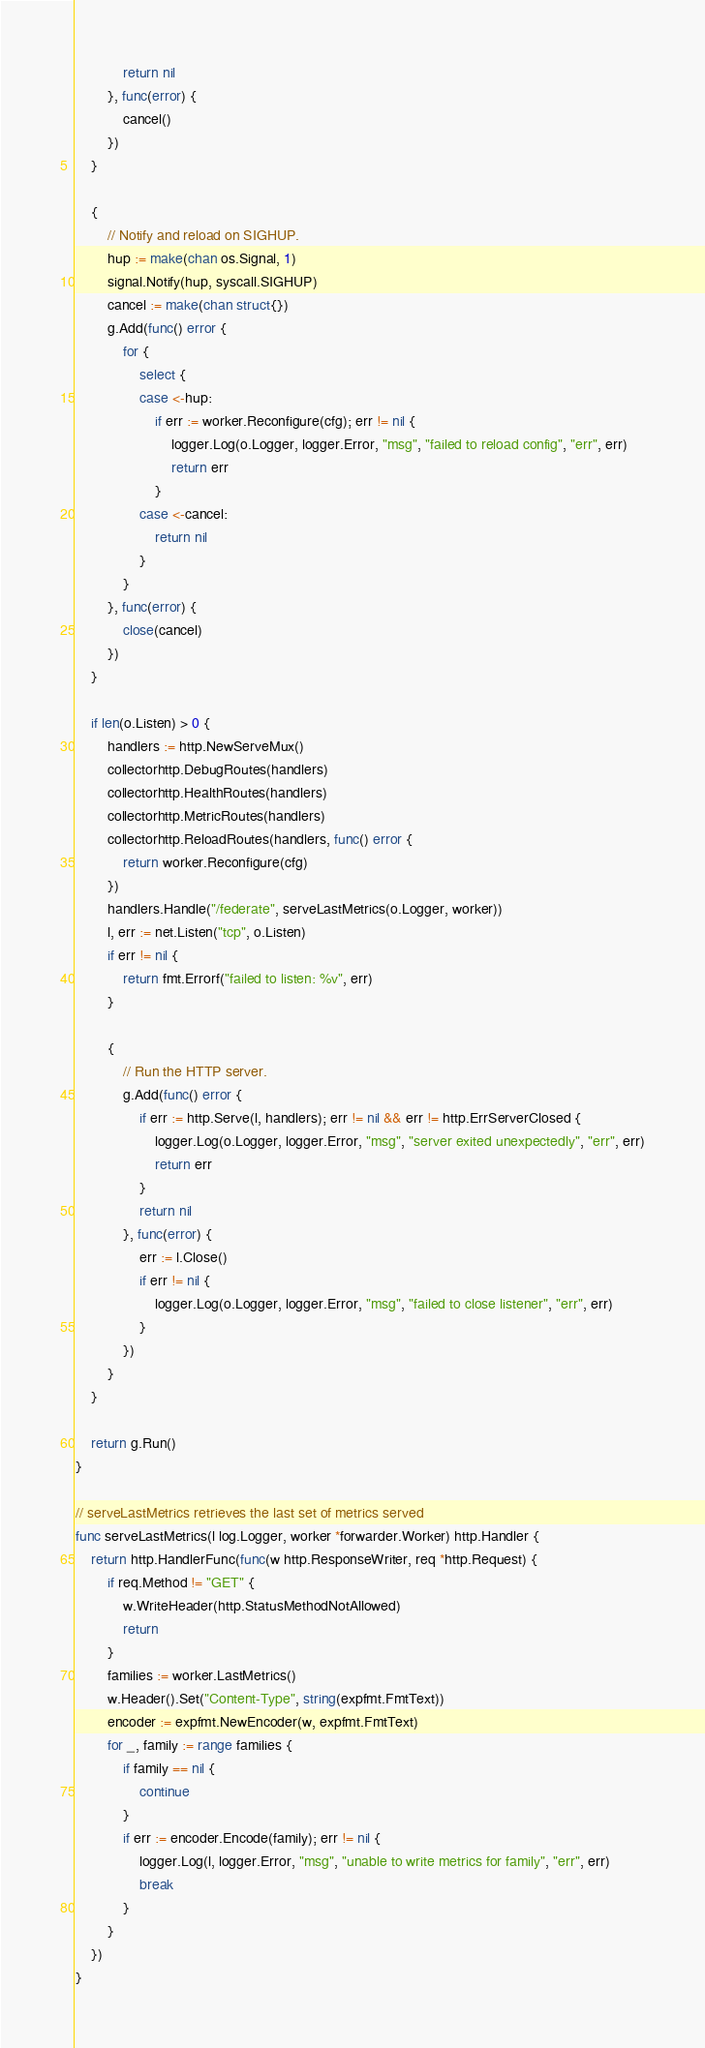Convert code to text. <code><loc_0><loc_0><loc_500><loc_500><_Go_>			return nil
		}, func(error) {
			cancel()
		})
	}

	{
		// Notify and reload on SIGHUP.
		hup := make(chan os.Signal, 1)
		signal.Notify(hup, syscall.SIGHUP)
		cancel := make(chan struct{})
		g.Add(func() error {
			for {
				select {
				case <-hup:
					if err := worker.Reconfigure(cfg); err != nil {
						logger.Log(o.Logger, logger.Error, "msg", "failed to reload config", "err", err)
						return err
					}
				case <-cancel:
					return nil
				}
			}
		}, func(error) {
			close(cancel)
		})
	}

	if len(o.Listen) > 0 {
		handlers := http.NewServeMux()
		collectorhttp.DebugRoutes(handlers)
		collectorhttp.HealthRoutes(handlers)
		collectorhttp.MetricRoutes(handlers)
		collectorhttp.ReloadRoutes(handlers, func() error {
			return worker.Reconfigure(cfg)
		})
		handlers.Handle("/federate", serveLastMetrics(o.Logger, worker))
		l, err := net.Listen("tcp", o.Listen)
		if err != nil {
			return fmt.Errorf("failed to listen: %v", err)
		}

		{
			// Run the HTTP server.
			g.Add(func() error {
				if err := http.Serve(l, handlers); err != nil && err != http.ErrServerClosed {
					logger.Log(o.Logger, logger.Error, "msg", "server exited unexpectedly", "err", err)
					return err
				}
				return nil
			}, func(error) {
				err := l.Close()
				if err != nil {
					logger.Log(o.Logger, logger.Error, "msg", "failed to close listener", "err", err)
				}
			})
		}
	}

	return g.Run()
}

// serveLastMetrics retrieves the last set of metrics served
func serveLastMetrics(l log.Logger, worker *forwarder.Worker) http.Handler {
	return http.HandlerFunc(func(w http.ResponseWriter, req *http.Request) {
		if req.Method != "GET" {
			w.WriteHeader(http.StatusMethodNotAllowed)
			return
		}
		families := worker.LastMetrics()
		w.Header().Set("Content-Type", string(expfmt.FmtText))
		encoder := expfmt.NewEncoder(w, expfmt.FmtText)
		for _, family := range families {
			if family == nil {
				continue
			}
			if err := encoder.Encode(family); err != nil {
				logger.Log(l, logger.Error, "msg", "unable to write metrics for family", "err", err)
				break
			}
		}
	})
}
</code> 